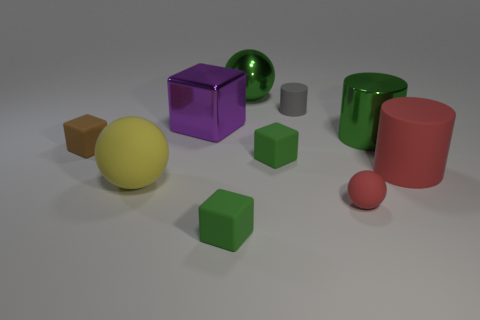Subtract all matte cylinders. How many cylinders are left? 1 Subtract all brown spheres. How many green cubes are left? 2 Subtract 1 cylinders. How many cylinders are left? 2 Subtract all brown blocks. How many blocks are left? 3 Subtract all blocks. How many objects are left? 6 Subtract all cyan blocks. Subtract all yellow spheres. How many blocks are left? 4 Subtract all big blue rubber cubes. Subtract all tiny green matte things. How many objects are left? 8 Add 3 large metal cubes. How many large metal cubes are left? 4 Add 5 large yellow objects. How many large yellow objects exist? 6 Subtract 0 cyan blocks. How many objects are left? 10 